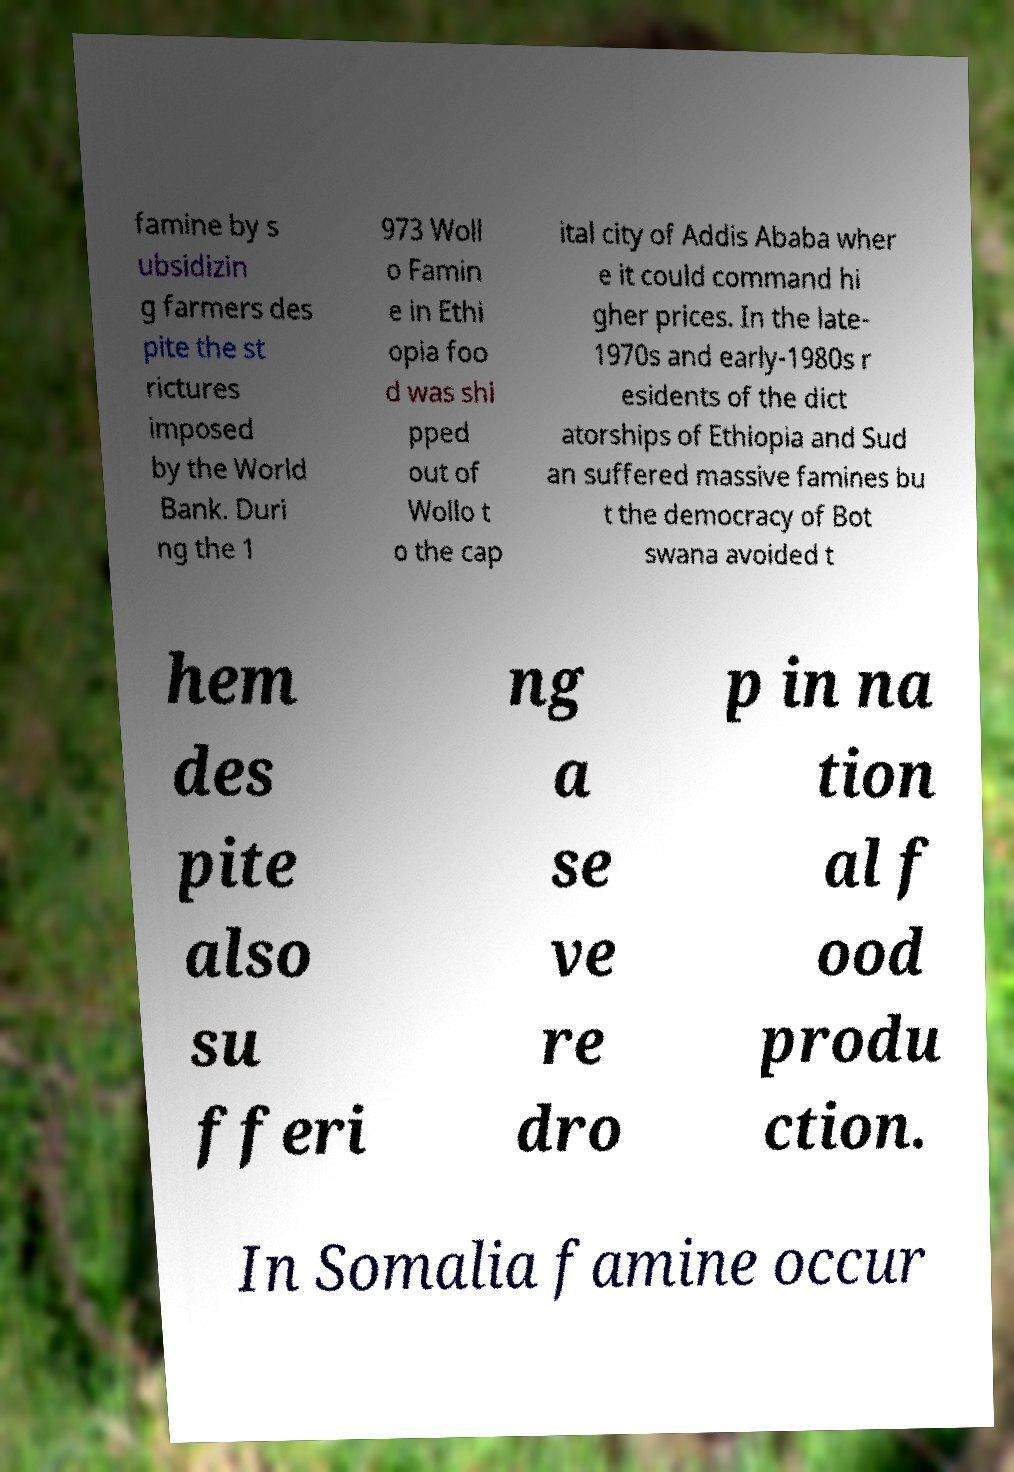Please read and relay the text visible in this image. What does it say? famine by s ubsidizin g farmers des pite the st rictures imposed by the World Bank. Duri ng the 1 973 Woll o Famin e in Ethi opia foo d was shi pped out of Wollo t o the cap ital city of Addis Ababa wher e it could command hi gher prices. In the late- 1970s and early-1980s r esidents of the dict atorships of Ethiopia and Sud an suffered massive famines bu t the democracy of Bot swana avoided t hem des pite also su fferi ng a se ve re dro p in na tion al f ood produ ction. In Somalia famine occur 